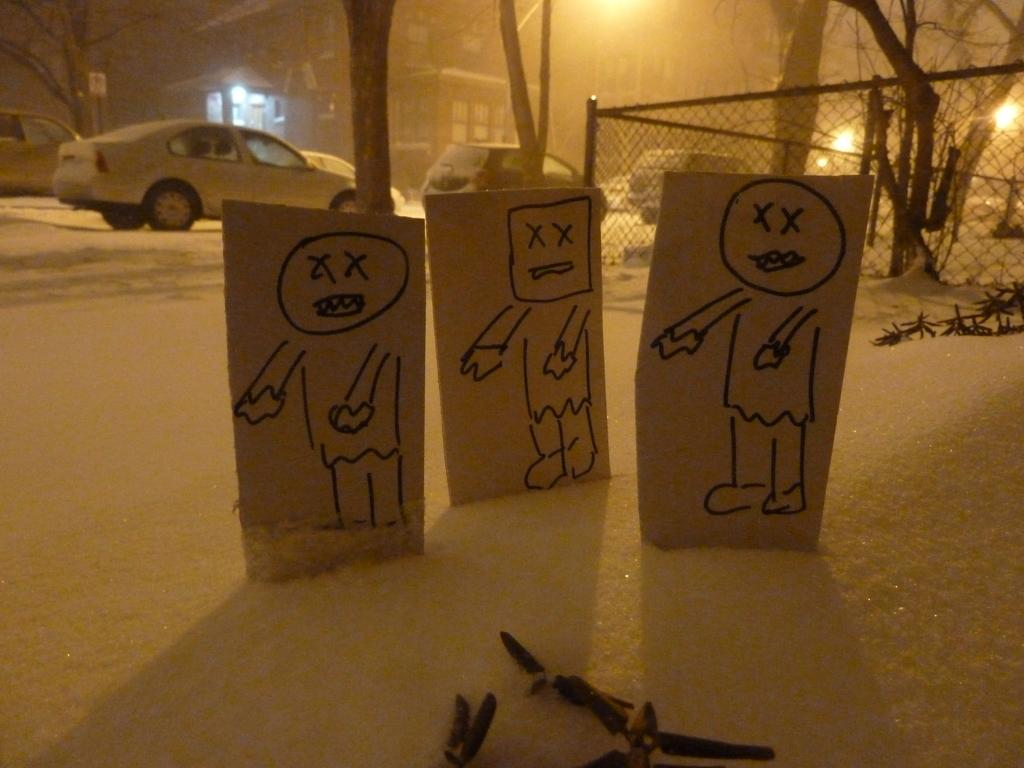What is on the snow in the image? There are boards and objects on the snow. What can be seen in the background of the image? There is a fence, trees, vehicles, a building, and a board on a pole in the background of the image. Are there any lights visible in the background of the image? Yes, there are lights visible in the background of the image. What type of quilt is being used to cover the growth in the image? There is no quilt or growth present in the image. What year is depicted in the image? The image does not depict a specific year; it is a snapshot of a scene at a particular moment. 